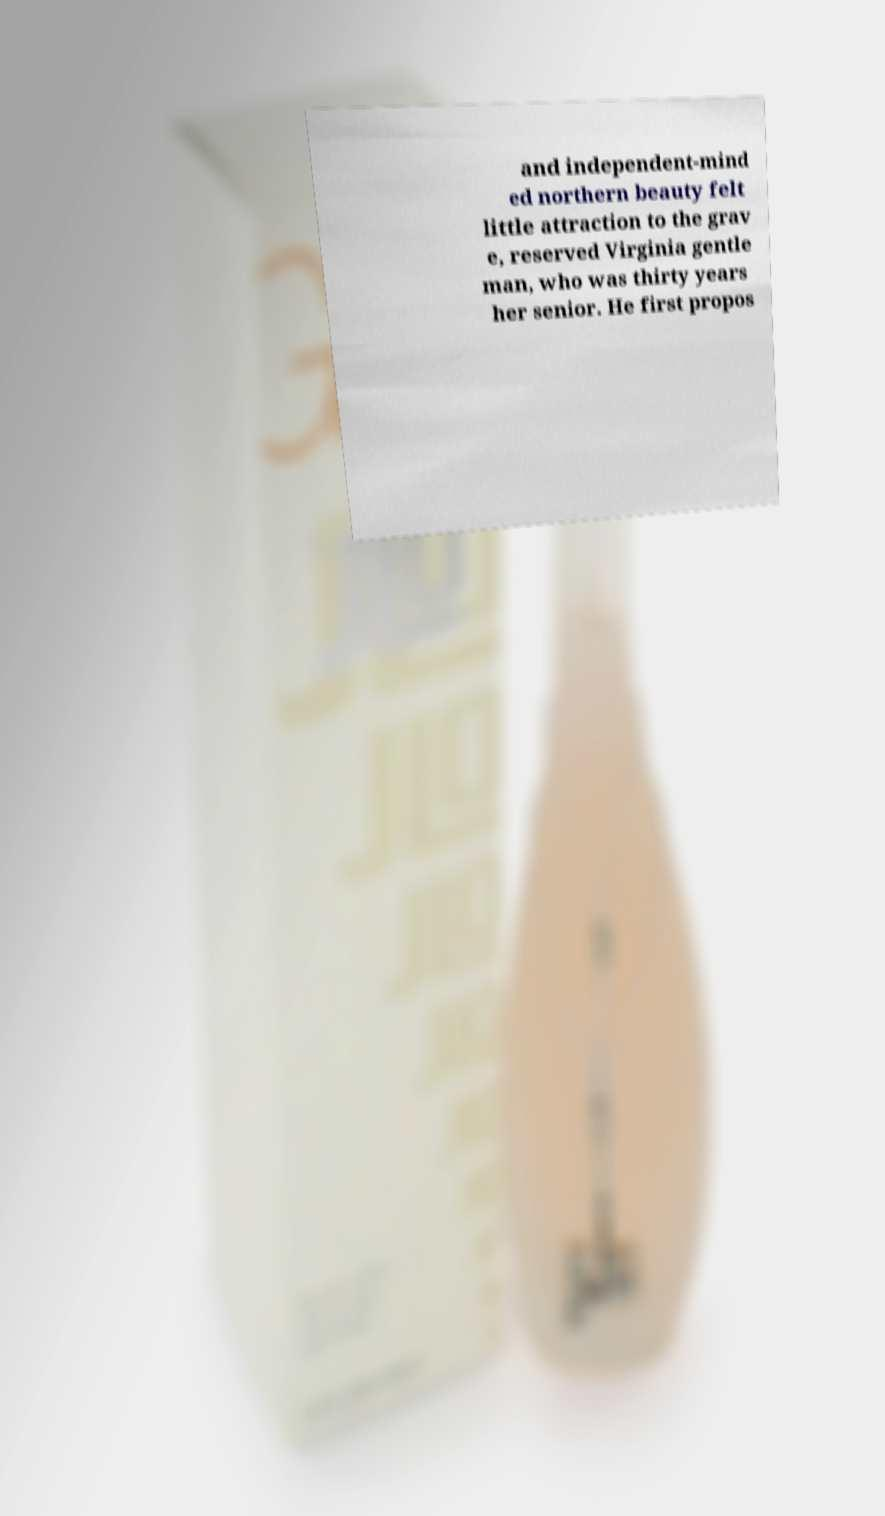Please read and relay the text visible in this image. What does it say? and independent-mind ed northern beauty felt little attraction to the grav e, reserved Virginia gentle man, who was thirty years her senior. He first propos 